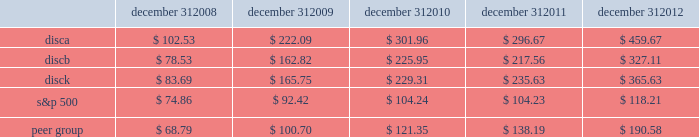Stock performance graph the following graph sets forth the cumulative total shareholder return on our series a common stock , series b common stock and series c common stock as compared with the cumulative total return of the companies listed in the standard and poor 2019s 500 stock index ( 201cs&p 500 index 201d ) and a peer group of companies comprised of cbs corporation class b common stock , news corporation class a common stock , scripps network interactive , inc. , time warner , inc. , viacom , inc .
Class b common stock and the walt disney company .
The graph assumes $ 100 originally invested on september 18 , 2008 , the date upon which our common stock began trading , in each of our series a common stock , series b common stock and series c common stock , the s&p 500 index , and the stock of our peer group companies , including reinvestment of dividends , for the period september 18 , 2008 through december 31 , 2008 and the years ended december 31 , 2009 , 2010 , 2011 , and 2012 .
December 31 , december 31 , december 31 , december 31 , december 31 .
Equity compensation plan information information regarding securities authorized for issuance under equity compensation plans will be set forth in our definitive proxy statement for our 2013 annual meeting of stockholders under the caption 201csecurities authorized for issuance under equity compensation plans , 201d which is incorporated herein by reference. .
What was the percentage cumulative total shareholder return on discb common stock from september 18 , 2008 to december 31 , 2012? 
Computations: ((327.11 - 100) / 100)
Answer: 2.2711. 